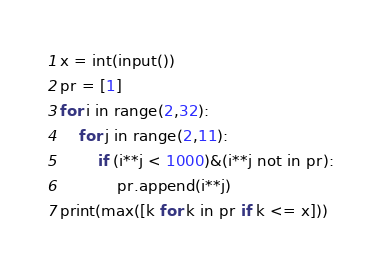Convert code to text. <code><loc_0><loc_0><loc_500><loc_500><_Python_>x = int(input())
pr = [1]
for i in range(2,32):
    for j in range(2,11):
        if (i**j < 1000)&(i**j not in pr):
            pr.append(i**j)
print(max([k for k in pr if k <= x]))</code> 